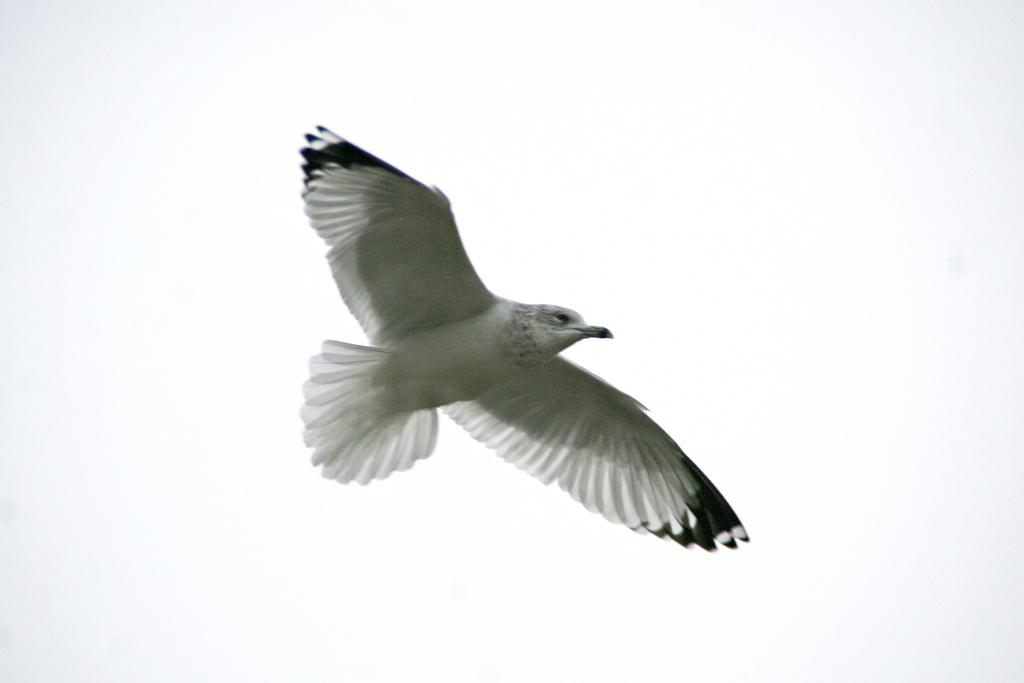What type of animal can be seen in the image? There is a bird in the image. What is the bird doing in the image? The bird is flying in the air. What can be seen in the background of the image? The sky is visible behind the bird. How many ears of corn are visible in the image? There are no ears of corn present in the image. What type of spiders can be seen crawling on the bird in the image? There are no spiders visible in the image, and the bird is flying, not crawling. 